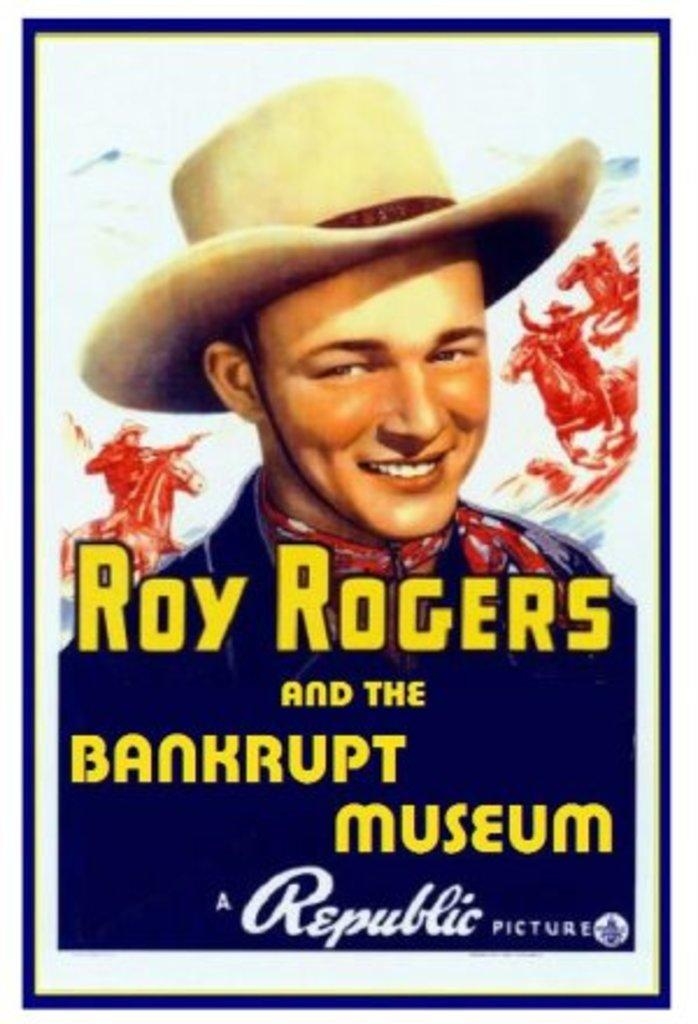<image>
Relay a brief, clear account of the picture shown. Poster for Roy Rogers and the Bankrupt Museum. 